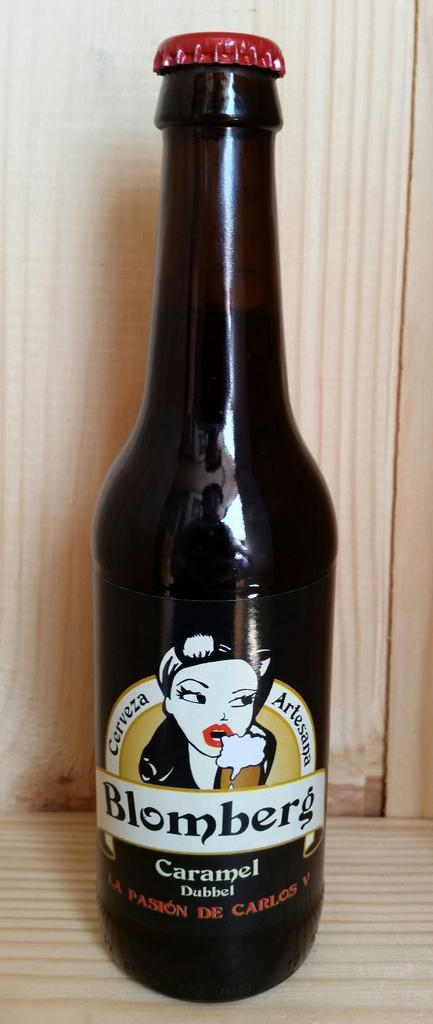<image>
Write a terse but informative summary of the picture. A bottle of Blomberg's Caramel Dubbel sits on a counter. 